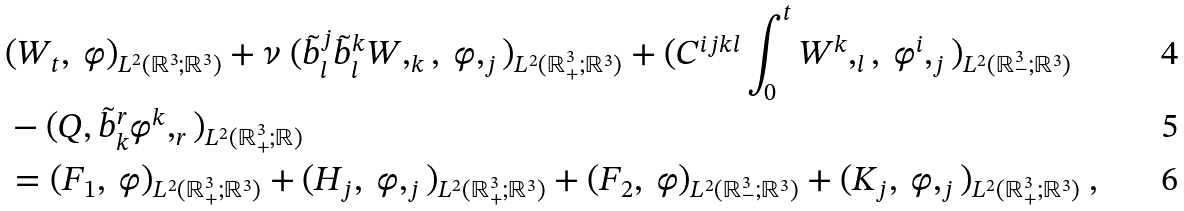Convert formula to latex. <formula><loc_0><loc_0><loc_500><loc_500>& ( W _ { t } , \ \varphi ) _ { L ^ { 2 } ( { \mathbb { R } } ^ { 3 } ; { \mathbb { R } } ^ { 3 } ) } + \nu \ ( \tilde { b } _ { l } ^ { j } \tilde { b } _ { l } ^ { k } W , _ { k } , \ \varphi , _ { j } ) _ { L ^ { 2 } ( { \mathbb { R } } ^ { 3 } _ { + } ; { \mathbb { R } } ^ { 3 } ) } + ( C ^ { i j k l } \int _ { 0 } ^ { t } W ^ { k } , _ { l } , \ \varphi ^ { i } , _ { j } ) _ { L ^ { 2 } ( { \mathbb { R } } ^ { 3 } _ { - } ; { \mathbb { R } } ^ { 3 } ) } \\ & - ( Q , \tilde { b } _ { k } ^ { r } \varphi ^ { k } , _ { r } ) _ { L ^ { 2 } ( { \mathbb { R } } ^ { 3 } _ { + } ; { \mathbb { R } } ) } \\ & = ( F _ { 1 } , \ \varphi ) _ { L ^ { 2 } ( { \mathbb { R } } ^ { 3 } _ { + } ; { \mathbb { R } } ^ { 3 } ) } + ( H _ { j } , \ \varphi , _ { j } ) _ { L ^ { 2 } ( { \mathbb { R } } ^ { 3 } _ { + } ; { \mathbb { R } } ^ { 3 } ) } + ( F _ { 2 } , \ \varphi ) _ { L ^ { 2 } ( { \mathbb { R } } ^ { 3 } _ { - } ; { \mathbb { R } } ^ { 3 } ) } + ( K _ { j } , \ \varphi , _ { j } ) _ { L ^ { 2 } ( { \mathbb { R } } ^ { 3 } _ { + } ; { \mathbb { R } } ^ { 3 } ) } \ ,</formula> 